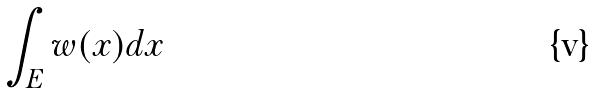<formula> <loc_0><loc_0><loc_500><loc_500>\int _ { E } w ( x ) d x</formula> 